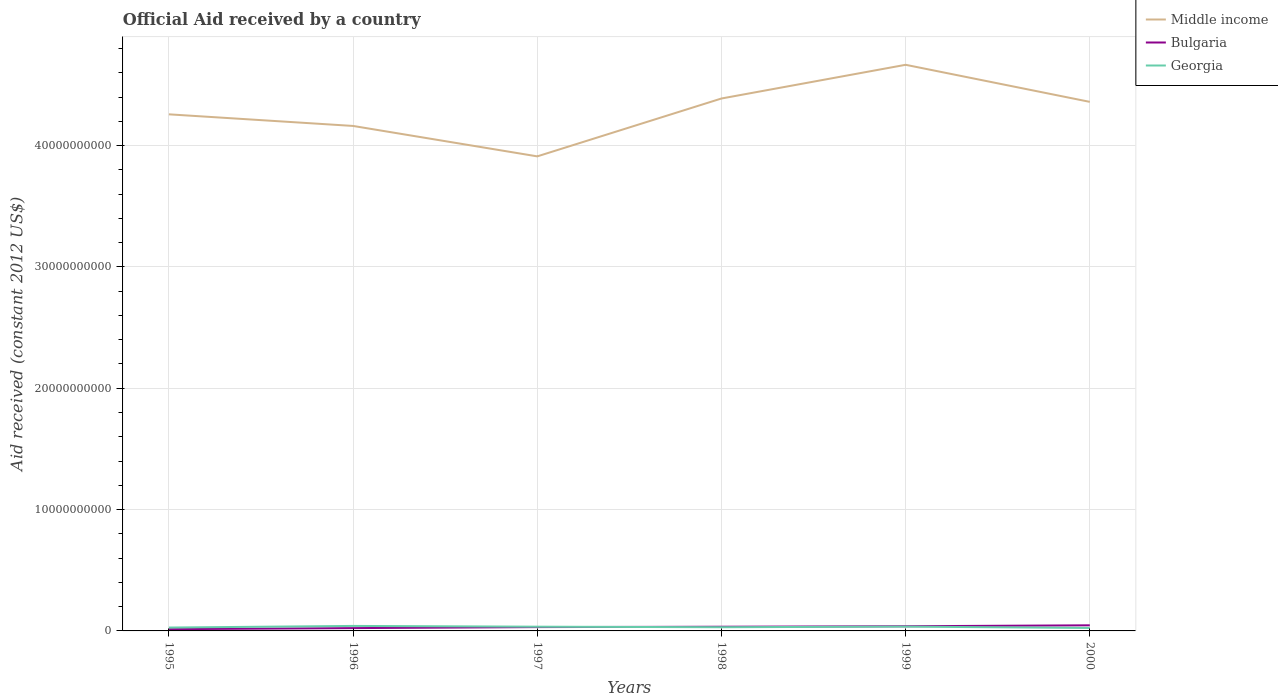Does the line corresponding to Georgia intersect with the line corresponding to Bulgaria?
Offer a very short reply. Yes. Across all years, what is the maximum net official aid received in Georgia?
Ensure brevity in your answer.  2.44e+08. What is the total net official aid received in Middle income in the graph?
Your response must be concise. 2.78e+08. What is the difference between the highest and the second highest net official aid received in Middle income?
Your answer should be compact. 7.55e+09. How many years are there in the graph?
Offer a very short reply. 6. Where does the legend appear in the graph?
Your response must be concise. Top right. How many legend labels are there?
Your answer should be very brief. 3. What is the title of the graph?
Give a very brief answer. Official Aid received by a country. Does "Iran" appear as one of the legend labels in the graph?
Provide a short and direct response. No. What is the label or title of the X-axis?
Keep it short and to the point. Years. What is the label or title of the Y-axis?
Keep it short and to the point. Aid received (constant 2012 US$). What is the Aid received (constant 2012 US$) in Middle income in 1995?
Give a very brief answer. 4.26e+1. What is the Aid received (constant 2012 US$) in Bulgaria in 1995?
Provide a short and direct response. 1.43e+08. What is the Aid received (constant 2012 US$) of Georgia in 1995?
Keep it short and to the point. 2.78e+08. What is the Aid received (constant 2012 US$) in Middle income in 1996?
Provide a short and direct response. 4.16e+1. What is the Aid received (constant 2012 US$) in Bulgaria in 1996?
Keep it short and to the point. 2.32e+08. What is the Aid received (constant 2012 US$) in Georgia in 1996?
Make the answer very short. 4.12e+08. What is the Aid received (constant 2012 US$) of Middle income in 1997?
Make the answer very short. 3.91e+1. What is the Aid received (constant 2012 US$) of Bulgaria in 1997?
Provide a succinct answer. 3.16e+08. What is the Aid received (constant 2012 US$) in Georgia in 1997?
Provide a succinct answer. 3.49e+08. What is the Aid received (constant 2012 US$) of Middle income in 1998?
Your answer should be compact. 4.39e+1. What is the Aid received (constant 2012 US$) of Bulgaria in 1998?
Provide a succinct answer. 3.45e+08. What is the Aid received (constant 2012 US$) in Georgia in 1998?
Ensure brevity in your answer.  3.06e+08. What is the Aid received (constant 2012 US$) in Middle income in 1999?
Give a very brief answer. 4.67e+1. What is the Aid received (constant 2012 US$) of Bulgaria in 1999?
Keep it short and to the point. 3.85e+08. What is the Aid received (constant 2012 US$) in Georgia in 1999?
Ensure brevity in your answer.  3.55e+08. What is the Aid received (constant 2012 US$) in Middle income in 2000?
Ensure brevity in your answer.  4.36e+1. What is the Aid received (constant 2012 US$) in Bulgaria in 2000?
Keep it short and to the point. 4.62e+08. What is the Aid received (constant 2012 US$) of Georgia in 2000?
Provide a short and direct response. 2.44e+08. Across all years, what is the maximum Aid received (constant 2012 US$) in Middle income?
Give a very brief answer. 4.67e+1. Across all years, what is the maximum Aid received (constant 2012 US$) in Bulgaria?
Your answer should be very brief. 4.62e+08. Across all years, what is the maximum Aid received (constant 2012 US$) in Georgia?
Give a very brief answer. 4.12e+08. Across all years, what is the minimum Aid received (constant 2012 US$) in Middle income?
Your answer should be compact. 3.91e+1. Across all years, what is the minimum Aid received (constant 2012 US$) of Bulgaria?
Provide a short and direct response. 1.43e+08. Across all years, what is the minimum Aid received (constant 2012 US$) in Georgia?
Provide a succinct answer. 2.44e+08. What is the total Aid received (constant 2012 US$) of Middle income in the graph?
Your response must be concise. 2.57e+11. What is the total Aid received (constant 2012 US$) in Bulgaria in the graph?
Your answer should be very brief. 1.88e+09. What is the total Aid received (constant 2012 US$) in Georgia in the graph?
Offer a very short reply. 1.94e+09. What is the difference between the Aid received (constant 2012 US$) of Middle income in 1995 and that in 1996?
Your answer should be very brief. 9.58e+08. What is the difference between the Aid received (constant 2012 US$) of Bulgaria in 1995 and that in 1996?
Give a very brief answer. -8.91e+07. What is the difference between the Aid received (constant 2012 US$) in Georgia in 1995 and that in 1996?
Give a very brief answer. -1.34e+08. What is the difference between the Aid received (constant 2012 US$) of Middle income in 1995 and that in 1997?
Your answer should be compact. 3.47e+09. What is the difference between the Aid received (constant 2012 US$) in Bulgaria in 1995 and that in 1997?
Provide a succinct answer. -1.72e+08. What is the difference between the Aid received (constant 2012 US$) of Georgia in 1995 and that in 1997?
Give a very brief answer. -7.05e+07. What is the difference between the Aid received (constant 2012 US$) in Middle income in 1995 and that in 1998?
Offer a very short reply. -1.30e+09. What is the difference between the Aid received (constant 2012 US$) in Bulgaria in 1995 and that in 1998?
Make the answer very short. -2.02e+08. What is the difference between the Aid received (constant 2012 US$) in Georgia in 1995 and that in 1998?
Offer a terse response. -2.76e+07. What is the difference between the Aid received (constant 2012 US$) of Middle income in 1995 and that in 1999?
Your answer should be very brief. -4.08e+09. What is the difference between the Aid received (constant 2012 US$) of Bulgaria in 1995 and that in 1999?
Your answer should be compact. -2.42e+08. What is the difference between the Aid received (constant 2012 US$) of Georgia in 1995 and that in 1999?
Provide a short and direct response. -7.69e+07. What is the difference between the Aid received (constant 2012 US$) in Middle income in 1995 and that in 2000?
Your answer should be very brief. -1.03e+09. What is the difference between the Aid received (constant 2012 US$) of Bulgaria in 1995 and that in 2000?
Your answer should be compact. -3.19e+08. What is the difference between the Aid received (constant 2012 US$) of Georgia in 1995 and that in 2000?
Offer a terse response. 3.45e+07. What is the difference between the Aid received (constant 2012 US$) of Middle income in 1996 and that in 1997?
Your answer should be compact. 2.51e+09. What is the difference between the Aid received (constant 2012 US$) in Bulgaria in 1996 and that in 1997?
Offer a terse response. -8.31e+07. What is the difference between the Aid received (constant 2012 US$) in Georgia in 1996 and that in 1997?
Keep it short and to the point. 6.32e+07. What is the difference between the Aid received (constant 2012 US$) of Middle income in 1996 and that in 1998?
Provide a short and direct response. -2.26e+09. What is the difference between the Aid received (constant 2012 US$) of Bulgaria in 1996 and that in 1998?
Give a very brief answer. -1.12e+08. What is the difference between the Aid received (constant 2012 US$) in Georgia in 1996 and that in 1998?
Provide a short and direct response. 1.06e+08. What is the difference between the Aid received (constant 2012 US$) of Middle income in 1996 and that in 1999?
Your answer should be very brief. -5.04e+09. What is the difference between the Aid received (constant 2012 US$) of Bulgaria in 1996 and that in 1999?
Provide a succinct answer. -1.53e+08. What is the difference between the Aid received (constant 2012 US$) of Georgia in 1996 and that in 1999?
Ensure brevity in your answer.  5.68e+07. What is the difference between the Aid received (constant 2012 US$) of Middle income in 1996 and that in 2000?
Keep it short and to the point. -1.98e+09. What is the difference between the Aid received (constant 2012 US$) in Bulgaria in 1996 and that in 2000?
Provide a short and direct response. -2.30e+08. What is the difference between the Aid received (constant 2012 US$) in Georgia in 1996 and that in 2000?
Your answer should be compact. 1.68e+08. What is the difference between the Aid received (constant 2012 US$) of Middle income in 1997 and that in 1998?
Provide a succinct answer. -4.77e+09. What is the difference between the Aid received (constant 2012 US$) in Bulgaria in 1997 and that in 1998?
Offer a terse response. -2.94e+07. What is the difference between the Aid received (constant 2012 US$) in Georgia in 1997 and that in 1998?
Provide a succinct answer. 4.29e+07. What is the difference between the Aid received (constant 2012 US$) in Middle income in 1997 and that in 1999?
Offer a terse response. -7.55e+09. What is the difference between the Aid received (constant 2012 US$) of Bulgaria in 1997 and that in 1999?
Ensure brevity in your answer.  -6.99e+07. What is the difference between the Aid received (constant 2012 US$) of Georgia in 1997 and that in 1999?
Offer a very short reply. -6.39e+06. What is the difference between the Aid received (constant 2012 US$) of Middle income in 1997 and that in 2000?
Make the answer very short. -4.49e+09. What is the difference between the Aid received (constant 2012 US$) of Bulgaria in 1997 and that in 2000?
Ensure brevity in your answer.  -1.47e+08. What is the difference between the Aid received (constant 2012 US$) of Georgia in 1997 and that in 2000?
Give a very brief answer. 1.05e+08. What is the difference between the Aid received (constant 2012 US$) of Middle income in 1998 and that in 1999?
Your answer should be compact. -2.78e+09. What is the difference between the Aid received (constant 2012 US$) of Bulgaria in 1998 and that in 1999?
Keep it short and to the point. -4.06e+07. What is the difference between the Aid received (constant 2012 US$) in Georgia in 1998 and that in 1999?
Offer a very short reply. -4.93e+07. What is the difference between the Aid received (constant 2012 US$) in Middle income in 1998 and that in 2000?
Provide a short and direct response. 2.78e+08. What is the difference between the Aid received (constant 2012 US$) of Bulgaria in 1998 and that in 2000?
Ensure brevity in your answer.  -1.17e+08. What is the difference between the Aid received (constant 2012 US$) in Georgia in 1998 and that in 2000?
Provide a succinct answer. 6.21e+07. What is the difference between the Aid received (constant 2012 US$) in Middle income in 1999 and that in 2000?
Ensure brevity in your answer.  3.06e+09. What is the difference between the Aid received (constant 2012 US$) of Bulgaria in 1999 and that in 2000?
Offer a very short reply. -7.66e+07. What is the difference between the Aid received (constant 2012 US$) in Georgia in 1999 and that in 2000?
Offer a terse response. 1.11e+08. What is the difference between the Aid received (constant 2012 US$) in Middle income in 1995 and the Aid received (constant 2012 US$) in Bulgaria in 1996?
Provide a succinct answer. 4.23e+1. What is the difference between the Aid received (constant 2012 US$) in Middle income in 1995 and the Aid received (constant 2012 US$) in Georgia in 1996?
Offer a terse response. 4.22e+1. What is the difference between the Aid received (constant 2012 US$) in Bulgaria in 1995 and the Aid received (constant 2012 US$) in Georgia in 1996?
Provide a short and direct response. -2.68e+08. What is the difference between the Aid received (constant 2012 US$) of Middle income in 1995 and the Aid received (constant 2012 US$) of Bulgaria in 1997?
Offer a very short reply. 4.23e+1. What is the difference between the Aid received (constant 2012 US$) of Middle income in 1995 and the Aid received (constant 2012 US$) of Georgia in 1997?
Offer a terse response. 4.22e+1. What is the difference between the Aid received (constant 2012 US$) in Bulgaria in 1995 and the Aid received (constant 2012 US$) in Georgia in 1997?
Ensure brevity in your answer.  -2.05e+08. What is the difference between the Aid received (constant 2012 US$) in Middle income in 1995 and the Aid received (constant 2012 US$) in Bulgaria in 1998?
Your answer should be compact. 4.22e+1. What is the difference between the Aid received (constant 2012 US$) of Middle income in 1995 and the Aid received (constant 2012 US$) of Georgia in 1998?
Make the answer very short. 4.23e+1. What is the difference between the Aid received (constant 2012 US$) of Bulgaria in 1995 and the Aid received (constant 2012 US$) of Georgia in 1998?
Ensure brevity in your answer.  -1.62e+08. What is the difference between the Aid received (constant 2012 US$) of Middle income in 1995 and the Aid received (constant 2012 US$) of Bulgaria in 1999?
Offer a terse response. 4.22e+1. What is the difference between the Aid received (constant 2012 US$) of Middle income in 1995 and the Aid received (constant 2012 US$) of Georgia in 1999?
Your answer should be very brief. 4.22e+1. What is the difference between the Aid received (constant 2012 US$) of Bulgaria in 1995 and the Aid received (constant 2012 US$) of Georgia in 1999?
Give a very brief answer. -2.12e+08. What is the difference between the Aid received (constant 2012 US$) in Middle income in 1995 and the Aid received (constant 2012 US$) in Bulgaria in 2000?
Give a very brief answer. 4.21e+1. What is the difference between the Aid received (constant 2012 US$) of Middle income in 1995 and the Aid received (constant 2012 US$) of Georgia in 2000?
Provide a succinct answer. 4.23e+1. What is the difference between the Aid received (constant 2012 US$) in Bulgaria in 1995 and the Aid received (constant 2012 US$) in Georgia in 2000?
Your answer should be very brief. -1.00e+08. What is the difference between the Aid received (constant 2012 US$) in Middle income in 1996 and the Aid received (constant 2012 US$) in Bulgaria in 1997?
Your response must be concise. 4.13e+1. What is the difference between the Aid received (constant 2012 US$) of Middle income in 1996 and the Aid received (constant 2012 US$) of Georgia in 1997?
Provide a succinct answer. 4.13e+1. What is the difference between the Aid received (constant 2012 US$) in Bulgaria in 1996 and the Aid received (constant 2012 US$) in Georgia in 1997?
Your answer should be compact. -1.16e+08. What is the difference between the Aid received (constant 2012 US$) in Middle income in 1996 and the Aid received (constant 2012 US$) in Bulgaria in 1998?
Ensure brevity in your answer.  4.13e+1. What is the difference between the Aid received (constant 2012 US$) in Middle income in 1996 and the Aid received (constant 2012 US$) in Georgia in 1998?
Make the answer very short. 4.13e+1. What is the difference between the Aid received (constant 2012 US$) of Bulgaria in 1996 and the Aid received (constant 2012 US$) of Georgia in 1998?
Your answer should be very brief. -7.32e+07. What is the difference between the Aid received (constant 2012 US$) in Middle income in 1996 and the Aid received (constant 2012 US$) in Bulgaria in 1999?
Your answer should be very brief. 4.12e+1. What is the difference between the Aid received (constant 2012 US$) in Middle income in 1996 and the Aid received (constant 2012 US$) in Georgia in 1999?
Offer a terse response. 4.13e+1. What is the difference between the Aid received (constant 2012 US$) of Bulgaria in 1996 and the Aid received (constant 2012 US$) of Georgia in 1999?
Keep it short and to the point. -1.23e+08. What is the difference between the Aid received (constant 2012 US$) in Middle income in 1996 and the Aid received (constant 2012 US$) in Bulgaria in 2000?
Offer a terse response. 4.12e+1. What is the difference between the Aid received (constant 2012 US$) in Middle income in 1996 and the Aid received (constant 2012 US$) in Georgia in 2000?
Provide a short and direct response. 4.14e+1. What is the difference between the Aid received (constant 2012 US$) of Bulgaria in 1996 and the Aid received (constant 2012 US$) of Georgia in 2000?
Keep it short and to the point. -1.11e+07. What is the difference between the Aid received (constant 2012 US$) in Middle income in 1997 and the Aid received (constant 2012 US$) in Bulgaria in 1998?
Offer a terse response. 3.88e+1. What is the difference between the Aid received (constant 2012 US$) of Middle income in 1997 and the Aid received (constant 2012 US$) of Georgia in 1998?
Give a very brief answer. 3.88e+1. What is the difference between the Aid received (constant 2012 US$) of Bulgaria in 1997 and the Aid received (constant 2012 US$) of Georgia in 1998?
Your answer should be very brief. 9.88e+06. What is the difference between the Aid received (constant 2012 US$) in Middle income in 1997 and the Aid received (constant 2012 US$) in Bulgaria in 1999?
Give a very brief answer. 3.87e+1. What is the difference between the Aid received (constant 2012 US$) of Middle income in 1997 and the Aid received (constant 2012 US$) of Georgia in 1999?
Provide a short and direct response. 3.88e+1. What is the difference between the Aid received (constant 2012 US$) of Bulgaria in 1997 and the Aid received (constant 2012 US$) of Georgia in 1999?
Provide a succinct answer. -3.94e+07. What is the difference between the Aid received (constant 2012 US$) of Middle income in 1997 and the Aid received (constant 2012 US$) of Bulgaria in 2000?
Your answer should be compact. 3.86e+1. What is the difference between the Aid received (constant 2012 US$) of Middle income in 1997 and the Aid received (constant 2012 US$) of Georgia in 2000?
Offer a terse response. 3.89e+1. What is the difference between the Aid received (constant 2012 US$) of Bulgaria in 1997 and the Aid received (constant 2012 US$) of Georgia in 2000?
Offer a terse response. 7.20e+07. What is the difference between the Aid received (constant 2012 US$) of Middle income in 1998 and the Aid received (constant 2012 US$) of Bulgaria in 1999?
Your response must be concise. 4.35e+1. What is the difference between the Aid received (constant 2012 US$) in Middle income in 1998 and the Aid received (constant 2012 US$) in Georgia in 1999?
Ensure brevity in your answer.  4.35e+1. What is the difference between the Aid received (constant 2012 US$) in Bulgaria in 1998 and the Aid received (constant 2012 US$) in Georgia in 1999?
Provide a short and direct response. -1.01e+07. What is the difference between the Aid received (constant 2012 US$) in Middle income in 1998 and the Aid received (constant 2012 US$) in Bulgaria in 2000?
Offer a terse response. 4.34e+1. What is the difference between the Aid received (constant 2012 US$) of Middle income in 1998 and the Aid received (constant 2012 US$) of Georgia in 2000?
Keep it short and to the point. 4.36e+1. What is the difference between the Aid received (constant 2012 US$) of Bulgaria in 1998 and the Aid received (constant 2012 US$) of Georgia in 2000?
Offer a terse response. 1.01e+08. What is the difference between the Aid received (constant 2012 US$) of Middle income in 1999 and the Aid received (constant 2012 US$) of Bulgaria in 2000?
Your answer should be very brief. 4.62e+1. What is the difference between the Aid received (constant 2012 US$) in Middle income in 1999 and the Aid received (constant 2012 US$) in Georgia in 2000?
Offer a very short reply. 4.64e+1. What is the difference between the Aid received (constant 2012 US$) in Bulgaria in 1999 and the Aid received (constant 2012 US$) in Georgia in 2000?
Offer a very short reply. 1.42e+08. What is the average Aid received (constant 2012 US$) in Middle income per year?
Your response must be concise. 4.29e+1. What is the average Aid received (constant 2012 US$) of Bulgaria per year?
Ensure brevity in your answer.  3.14e+08. What is the average Aid received (constant 2012 US$) in Georgia per year?
Give a very brief answer. 3.24e+08. In the year 1995, what is the difference between the Aid received (constant 2012 US$) in Middle income and Aid received (constant 2012 US$) in Bulgaria?
Ensure brevity in your answer.  4.24e+1. In the year 1995, what is the difference between the Aid received (constant 2012 US$) of Middle income and Aid received (constant 2012 US$) of Georgia?
Your answer should be compact. 4.23e+1. In the year 1995, what is the difference between the Aid received (constant 2012 US$) in Bulgaria and Aid received (constant 2012 US$) in Georgia?
Provide a short and direct response. -1.35e+08. In the year 1996, what is the difference between the Aid received (constant 2012 US$) in Middle income and Aid received (constant 2012 US$) in Bulgaria?
Offer a very short reply. 4.14e+1. In the year 1996, what is the difference between the Aid received (constant 2012 US$) of Middle income and Aid received (constant 2012 US$) of Georgia?
Make the answer very short. 4.12e+1. In the year 1996, what is the difference between the Aid received (constant 2012 US$) of Bulgaria and Aid received (constant 2012 US$) of Georgia?
Provide a short and direct response. -1.79e+08. In the year 1997, what is the difference between the Aid received (constant 2012 US$) of Middle income and Aid received (constant 2012 US$) of Bulgaria?
Provide a succinct answer. 3.88e+1. In the year 1997, what is the difference between the Aid received (constant 2012 US$) of Middle income and Aid received (constant 2012 US$) of Georgia?
Your answer should be very brief. 3.88e+1. In the year 1997, what is the difference between the Aid received (constant 2012 US$) in Bulgaria and Aid received (constant 2012 US$) in Georgia?
Keep it short and to the point. -3.30e+07. In the year 1998, what is the difference between the Aid received (constant 2012 US$) in Middle income and Aid received (constant 2012 US$) in Bulgaria?
Give a very brief answer. 4.35e+1. In the year 1998, what is the difference between the Aid received (constant 2012 US$) in Middle income and Aid received (constant 2012 US$) in Georgia?
Your response must be concise. 4.36e+1. In the year 1998, what is the difference between the Aid received (constant 2012 US$) in Bulgaria and Aid received (constant 2012 US$) in Georgia?
Provide a succinct answer. 3.92e+07. In the year 1999, what is the difference between the Aid received (constant 2012 US$) in Middle income and Aid received (constant 2012 US$) in Bulgaria?
Give a very brief answer. 4.63e+1. In the year 1999, what is the difference between the Aid received (constant 2012 US$) in Middle income and Aid received (constant 2012 US$) in Georgia?
Your response must be concise. 4.63e+1. In the year 1999, what is the difference between the Aid received (constant 2012 US$) of Bulgaria and Aid received (constant 2012 US$) of Georgia?
Your answer should be compact. 3.05e+07. In the year 2000, what is the difference between the Aid received (constant 2012 US$) in Middle income and Aid received (constant 2012 US$) in Bulgaria?
Provide a succinct answer. 4.31e+1. In the year 2000, what is the difference between the Aid received (constant 2012 US$) in Middle income and Aid received (constant 2012 US$) in Georgia?
Offer a terse response. 4.34e+1. In the year 2000, what is the difference between the Aid received (constant 2012 US$) in Bulgaria and Aid received (constant 2012 US$) in Georgia?
Your answer should be very brief. 2.19e+08. What is the ratio of the Aid received (constant 2012 US$) of Middle income in 1995 to that in 1996?
Provide a short and direct response. 1.02. What is the ratio of the Aid received (constant 2012 US$) of Bulgaria in 1995 to that in 1996?
Keep it short and to the point. 0.62. What is the ratio of the Aid received (constant 2012 US$) of Georgia in 1995 to that in 1996?
Keep it short and to the point. 0.68. What is the ratio of the Aid received (constant 2012 US$) in Middle income in 1995 to that in 1997?
Make the answer very short. 1.09. What is the ratio of the Aid received (constant 2012 US$) in Bulgaria in 1995 to that in 1997?
Provide a succinct answer. 0.45. What is the ratio of the Aid received (constant 2012 US$) of Georgia in 1995 to that in 1997?
Provide a succinct answer. 0.8. What is the ratio of the Aid received (constant 2012 US$) of Middle income in 1995 to that in 1998?
Ensure brevity in your answer.  0.97. What is the ratio of the Aid received (constant 2012 US$) in Bulgaria in 1995 to that in 1998?
Make the answer very short. 0.42. What is the ratio of the Aid received (constant 2012 US$) in Georgia in 1995 to that in 1998?
Offer a very short reply. 0.91. What is the ratio of the Aid received (constant 2012 US$) in Middle income in 1995 to that in 1999?
Give a very brief answer. 0.91. What is the ratio of the Aid received (constant 2012 US$) of Bulgaria in 1995 to that in 1999?
Ensure brevity in your answer.  0.37. What is the ratio of the Aid received (constant 2012 US$) in Georgia in 1995 to that in 1999?
Your answer should be very brief. 0.78. What is the ratio of the Aid received (constant 2012 US$) in Middle income in 1995 to that in 2000?
Your answer should be compact. 0.98. What is the ratio of the Aid received (constant 2012 US$) of Bulgaria in 1995 to that in 2000?
Offer a very short reply. 0.31. What is the ratio of the Aid received (constant 2012 US$) of Georgia in 1995 to that in 2000?
Your response must be concise. 1.14. What is the ratio of the Aid received (constant 2012 US$) in Middle income in 1996 to that in 1997?
Give a very brief answer. 1.06. What is the ratio of the Aid received (constant 2012 US$) in Bulgaria in 1996 to that in 1997?
Keep it short and to the point. 0.74. What is the ratio of the Aid received (constant 2012 US$) of Georgia in 1996 to that in 1997?
Your answer should be very brief. 1.18. What is the ratio of the Aid received (constant 2012 US$) in Middle income in 1996 to that in 1998?
Your response must be concise. 0.95. What is the ratio of the Aid received (constant 2012 US$) of Bulgaria in 1996 to that in 1998?
Give a very brief answer. 0.67. What is the ratio of the Aid received (constant 2012 US$) in Georgia in 1996 to that in 1998?
Your answer should be compact. 1.35. What is the ratio of the Aid received (constant 2012 US$) of Middle income in 1996 to that in 1999?
Provide a short and direct response. 0.89. What is the ratio of the Aid received (constant 2012 US$) in Bulgaria in 1996 to that in 1999?
Ensure brevity in your answer.  0.6. What is the ratio of the Aid received (constant 2012 US$) of Georgia in 1996 to that in 1999?
Make the answer very short. 1.16. What is the ratio of the Aid received (constant 2012 US$) of Middle income in 1996 to that in 2000?
Offer a terse response. 0.95. What is the ratio of the Aid received (constant 2012 US$) in Bulgaria in 1996 to that in 2000?
Make the answer very short. 0.5. What is the ratio of the Aid received (constant 2012 US$) of Georgia in 1996 to that in 2000?
Offer a very short reply. 1.69. What is the ratio of the Aid received (constant 2012 US$) in Middle income in 1997 to that in 1998?
Ensure brevity in your answer.  0.89. What is the ratio of the Aid received (constant 2012 US$) of Bulgaria in 1997 to that in 1998?
Offer a terse response. 0.91. What is the ratio of the Aid received (constant 2012 US$) of Georgia in 1997 to that in 1998?
Your answer should be compact. 1.14. What is the ratio of the Aid received (constant 2012 US$) in Middle income in 1997 to that in 1999?
Your answer should be very brief. 0.84. What is the ratio of the Aid received (constant 2012 US$) in Bulgaria in 1997 to that in 1999?
Ensure brevity in your answer.  0.82. What is the ratio of the Aid received (constant 2012 US$) in Middle income in 1997 to that in 2000?
Your response must be concise. 0.9. What is the ratio of the Aid received (constant 2012 US$) in Bulgaria in 1997 to that in 2000?
Your answer should be compact. 0.68. What is the ratio of the Aid received (constant 2012 US$) of Georgia in 1997 to that in 2000?
Offer a terse response. 1.43. What is the ratio of the Aid received (constant 2012 US$) of Middle income in 1998 to that in 1999?
Make the answer very short. 0.94. What is the ratio of the Aid received (constant 2012 US$) of Bulgaria in 1998 to that in 1999?
Keep it short and to the point. 0.89. What is the ratio of the Aid received (constant 2012 US$) of Georgia in 1998 to that in 1999?
Your answer should be compact. 0.86. What is the ratio of the Aid received (constant 2012 US$) in Middle income in 1998 to that in 2000?
Offer a terse response. 1.01. What is the ratio of the Aid received (constant 2012 US$) in Bulgaria in 1998 to that in 2000?
Offer a very short reply. 0.75. What is the ratio of the Aid received (constant 2012 US$) in Georgia in 1998 to that in 2000?
Make the answer very short. 1.26. What is the ratio of the Aid received (constant 2012 US$) in Middle income in 1999 to that in 2000?
Your response must be concise. 1.07. What is the ratio of the Aid received (constant 2012 US$) in Bulgaria in 1999 to that in 2000?
Make the answer very short. 0.83. What is the ratio of the Aid received (constant 2012 US$) of Georgia in 1999 to that in 2000?
Provide a short and direct response. 1.46. What is the difference between the highest and the second highest Aid received (constant 2012 US$) of Middle income?
Your answer should be compact. 2.78e+09. What is the difference between the highest and the second highest Aid received (constant 2012 US$) in Bulgaria?
Provide a succinct answer. 7.66e+07. What is the difference between the highest and the second highest Aid received (constant 2012 US$) of Georgia?
Your answer should be compact. 5.68e+07. What is the difference between the highest and the lowest Aid received (constant 2012 US$) in Middle income?
Provide a short and direct response. 7.55e+09. What is the difference between the highest and the lowest Aid received (constant 2012 US$) in Bulgaria?
Provide a succinct answer. 3.19e+08. What is the difference between the highest and the lowest Aid received (constant 2012 US$) of Georgia?
Make the answer very short. 1.68e+08. 